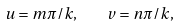<formula> <loc_0><loc_0><loc_500><loc_500>u = m \pi / k , \quad v = n \pi / k ,</formula> 